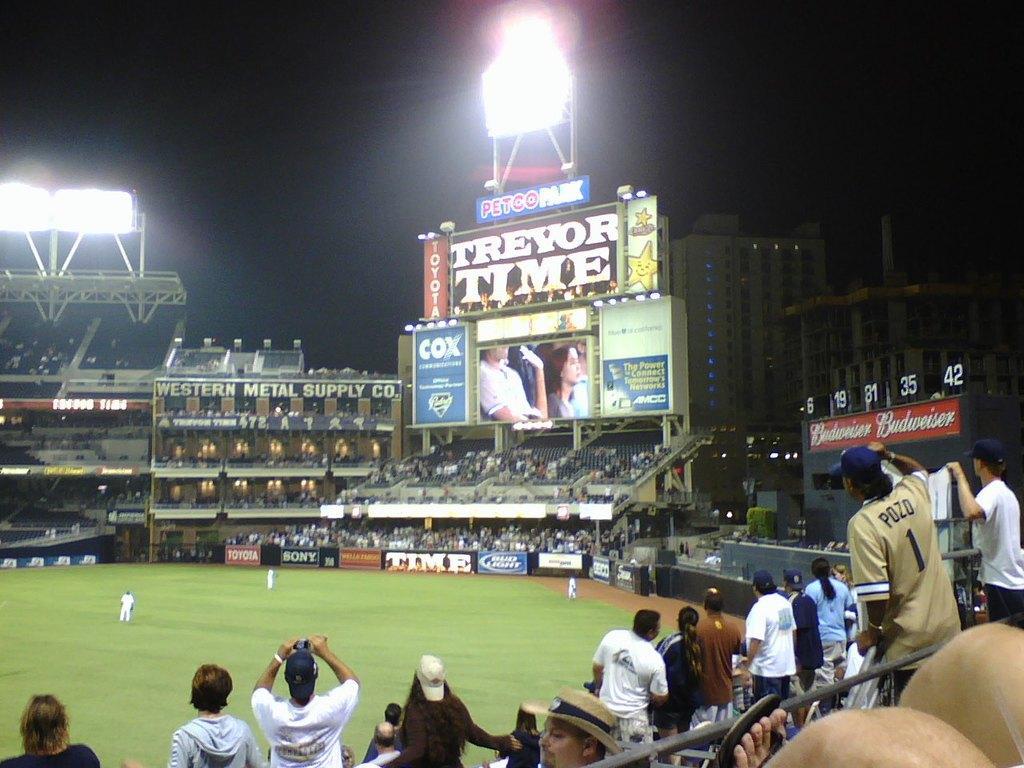How would you summarize this image in a sentence or two? In this image, we can see a stadium. At the bottom of the image, we can see people. Few people are holding some objects. Here there is a rod. In the background, we can see the ground, people, banners, screen, buildings, lights and dark view. 